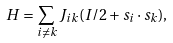<formula> <loc_0><loc_0><loc_500><loc_500>H = \sum _ { i \neq k } J _ { i k } ( I / 2 + { s _ { i } \cdot s _ { k } } ) ,</formula> 